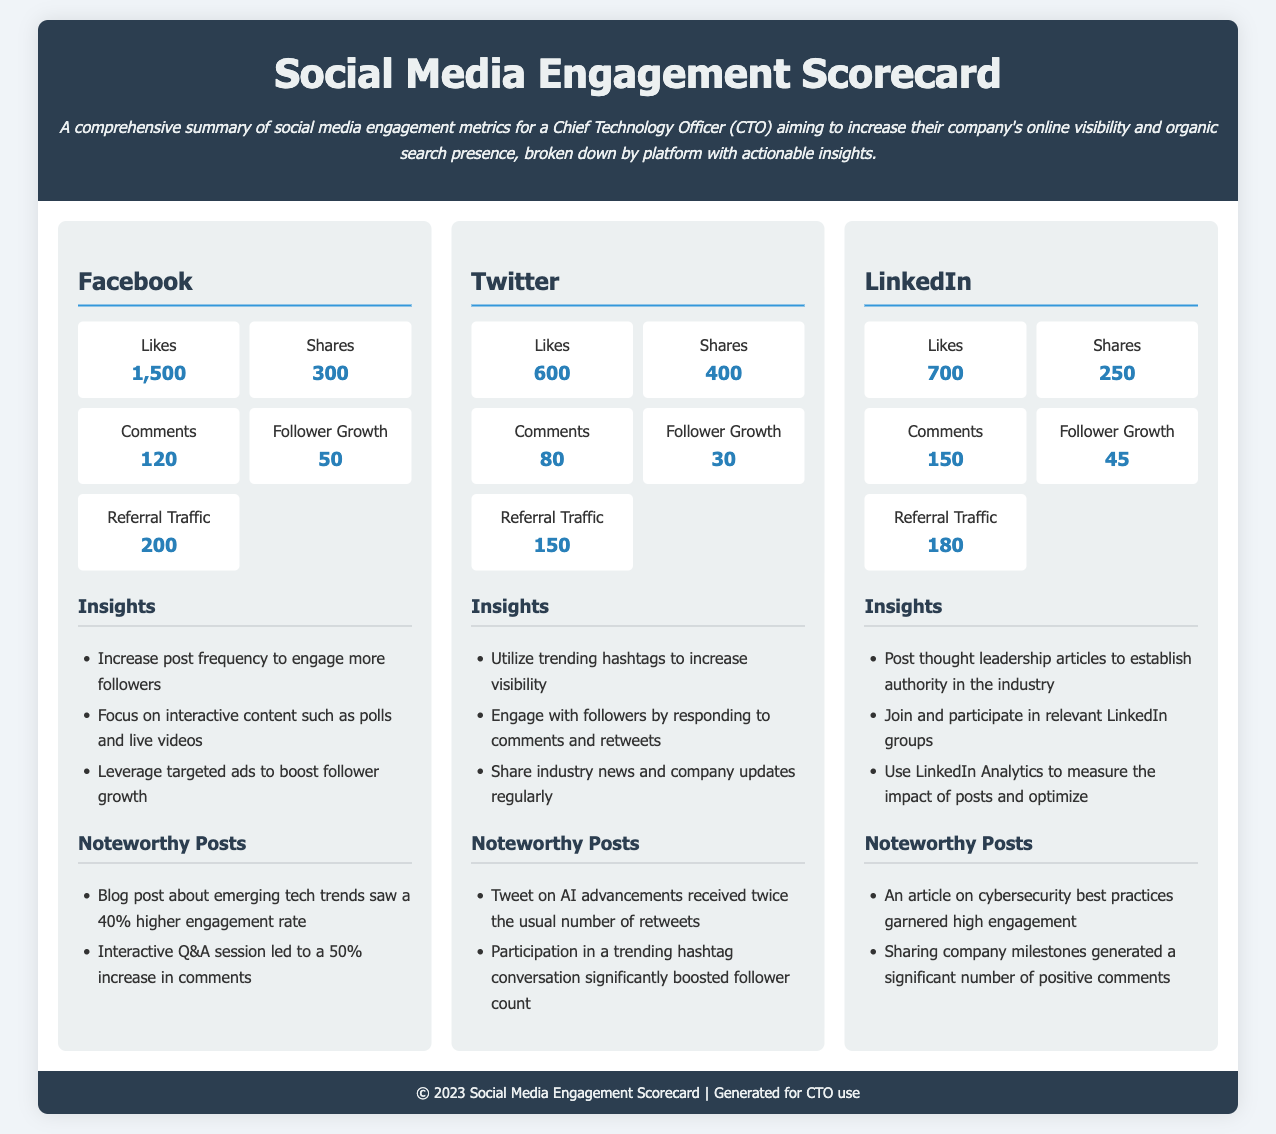What are the likes on Facebook? The document states that Facebook has 1,500 likes.
Answer: 1,500 What is the follower growth on Twitter? The follower growth metric for Twitter is provided as 30.
Answer: 30 Which platform had the most shares? By comparing the share counts listed, Facebook has the most shares at 300.
Answer: Facebook What actionable insight is provided for LinkedIn? The document mentions posting thought leadership articles as an insight for LinkedIn.
Answer: Post thought leadership articles How many comments did LinkedIn receive? The number of comments listed for LinkedIn is 150.
Answer: 150 Which platform had the highest referral traffic? Referral traffic is highest on Facebook, with a value of 200.
Answer: Facebook What noteworthy post on Twitter received significantly boosted engagement? The tweet on AI advancements is noted as receiving twice the usual number of retweets.
Answer: Tweet on AI advancements How many shares were recorded on LinkedIn? The document states that LinkedIn had 250 shares.
Answer: 250 What is the total number of likes across all platforms? The likes total is 1,500 (Facebook) + 600 (Twitter) + 700 (LinkedIn) = 2,800.
Answer: 2,800 